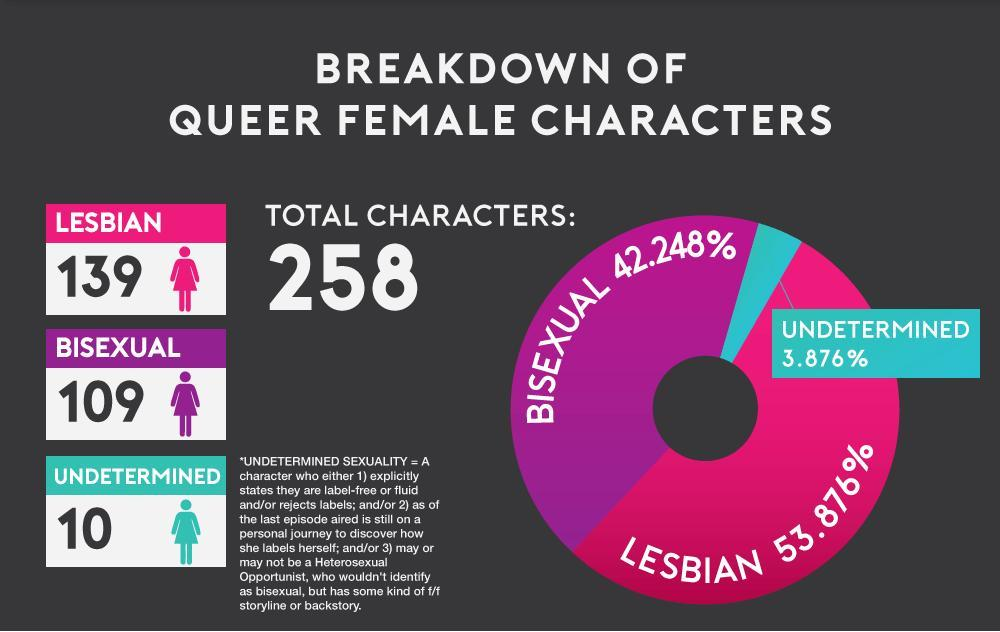What color represents "Lesbian" in the pie chart, Pink, blue or purple?
Answer the question with a short phrase. Pink What color represents "Undetermined" in the pie chart, Pink, blue or purple? blue What percentage makes up the Lesbian and Bisexual queer female characters? 96.124% How many Queer female characters are there in the infographic other than Lesbian? 119 